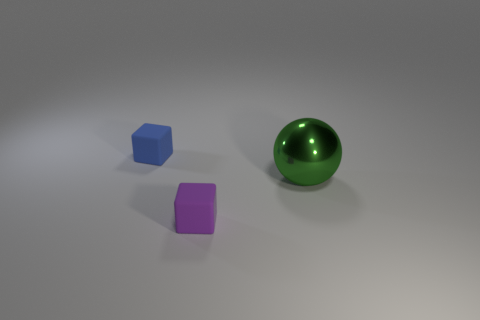Is there anything else that is the same size as the sphere?
Give a very brief answer. No. Is the small thing in front of the blue matte object made of the same material as the tiny block behind the ball?
Provide a short and direct response. Yes. There is a green sphere that is to the right of the cube on the left side of the purple cube; what is it made of?
Your answer should be compact. Metal. What is the shape of the object that is on the left side of the rubber block in front of the tiny cube behind the small purple matte thing?
Your answer should be very brief. Cube. There is another tiny object that is the same shape as the purple rubber thing; what is it made of?
Ensure brevity in your answer.  Rubber. How many green things are there?
Give a very brief answer. 1. There is a large object that is behind the purple thing; what is its shape?
Provide a short and direct response. Sphere. There is a matte object that is on the left side of the cube in front of the small rubber thing that is behind the purple cube; what color is it?
Your response must be concise. Blue. There is a small blue object that is made of the same material as the small purple cube; what shape is it?
Make the answer very short. Cube. Is the number of small blue metal spheres less than the number of blue matte cubes?
Your answer should be very brief. Yes. 